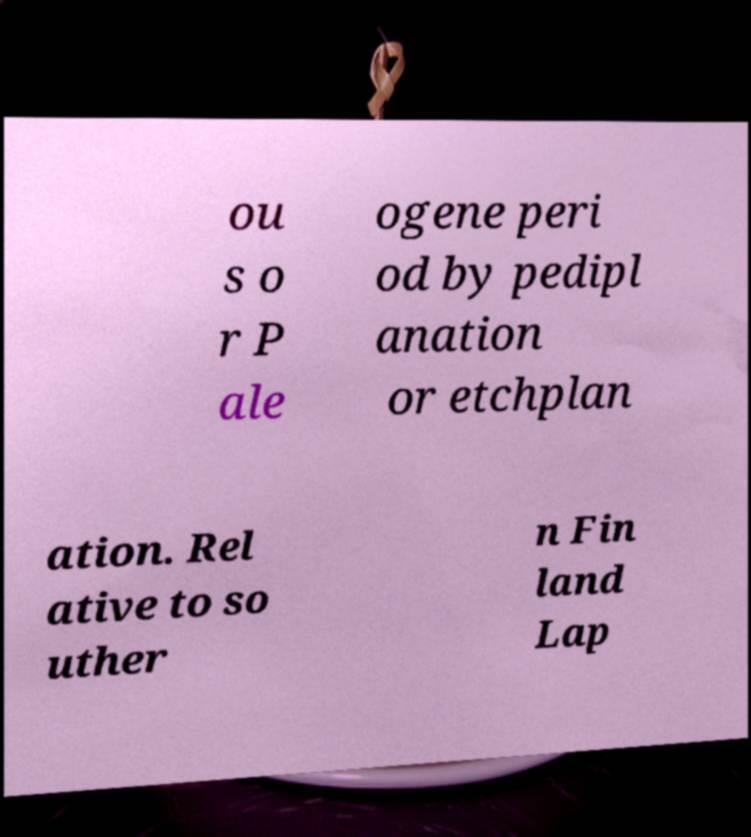Can you read and provide the text displayed in the image?This photo seems to have some interesting text. Can you extract and type it out for me? ou s o r P ale ogene peri od by pedipl anation or etchplan ation. Rel ative to so uther n Fin land Lap 